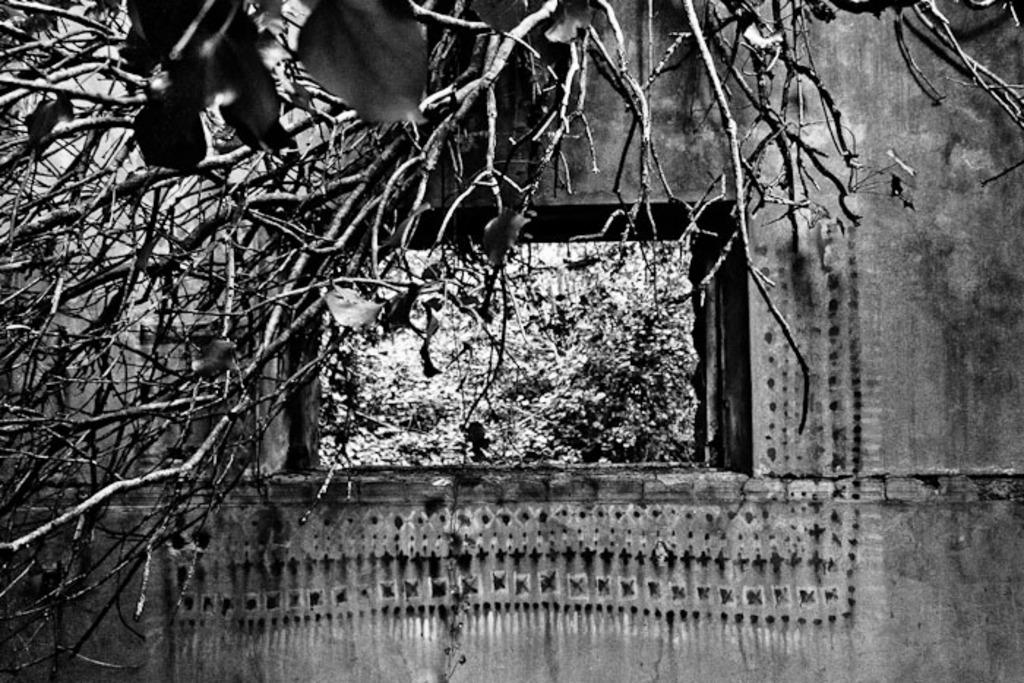What is the color scheme of the image? The image is black and white. What natural element can be seen in the image? There is a tree in the image. What man-made structure is present in the image? There is a building in the image. What feature of the building is visible in the image? There is a window in the building. What can be seen through the window in the image? Trees are visible through the window. What type of jelly is being used to push the tree in the image? There is no jelly or pushing action involving the tree in the image. 